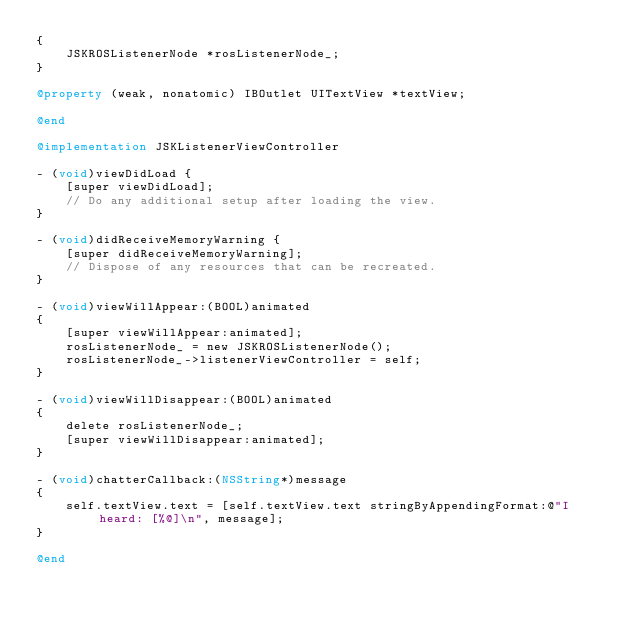<code> <loc_0><loc_0><loc_500><loc_500><_ObjectiveC_>{
    JSKROSListenerNode *rosListenerNode_;
}

@property (weak, nonatomic) IBOutlet UITextView *textView;

@end

@implementation JSKListenerViewController

- (void)viewDidLoad {
    [super viewDidLoad];
    // Do any additional setup after loading the view.
}

- (void)didReceiveMemoryWarning {
    [super didReceiveMemoryWarning];
    // Dispose of any resources that can be recreated.
}

- (void)viewWillAppear:(BOOL)animated
{
    [super viewWillAppear:animated];
    rosListenerNode_ = new JSKROSListenerNode();
    rosListenerNode_->listenerViewController = self;
}

- (void)viewWillDisappear:(BOOL)animated
{
    delete rosListenerNode_;
    [super viewWillDisappear:animated];
}

- (void)chatterCallback:(NSString*)message
{
    self.textView.text = [self.textView.text stringByAppendingFormat:@"I heard: [%@]\n", message];
}

@end
</code> 